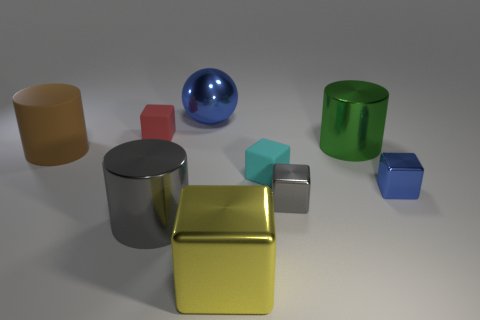How do the objects' materials contribute to the image's overall look? The objects in the image have different materials that affect their appearance. The matte objects, like the beige cylinder and the green hollow cylinder, absorb more light, giving them a soft, subdued look. The glossy objects, like the gold cube and the gray cylinder, reflect light, adding highlights and contributing to a more dramatic and varied visual texture. These material properties work together to create a compelling contrast of finishes, enhancing the image's aesthetic appeal. 